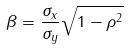Convert formula to latex. <formula><loc_0><loc_0><loc_500><loc_500>\beta = \frac { \sigma _ { x } } { \sigma _ { y } } \sqrt { 1 - \rho ^ { 2 } }</formula> 